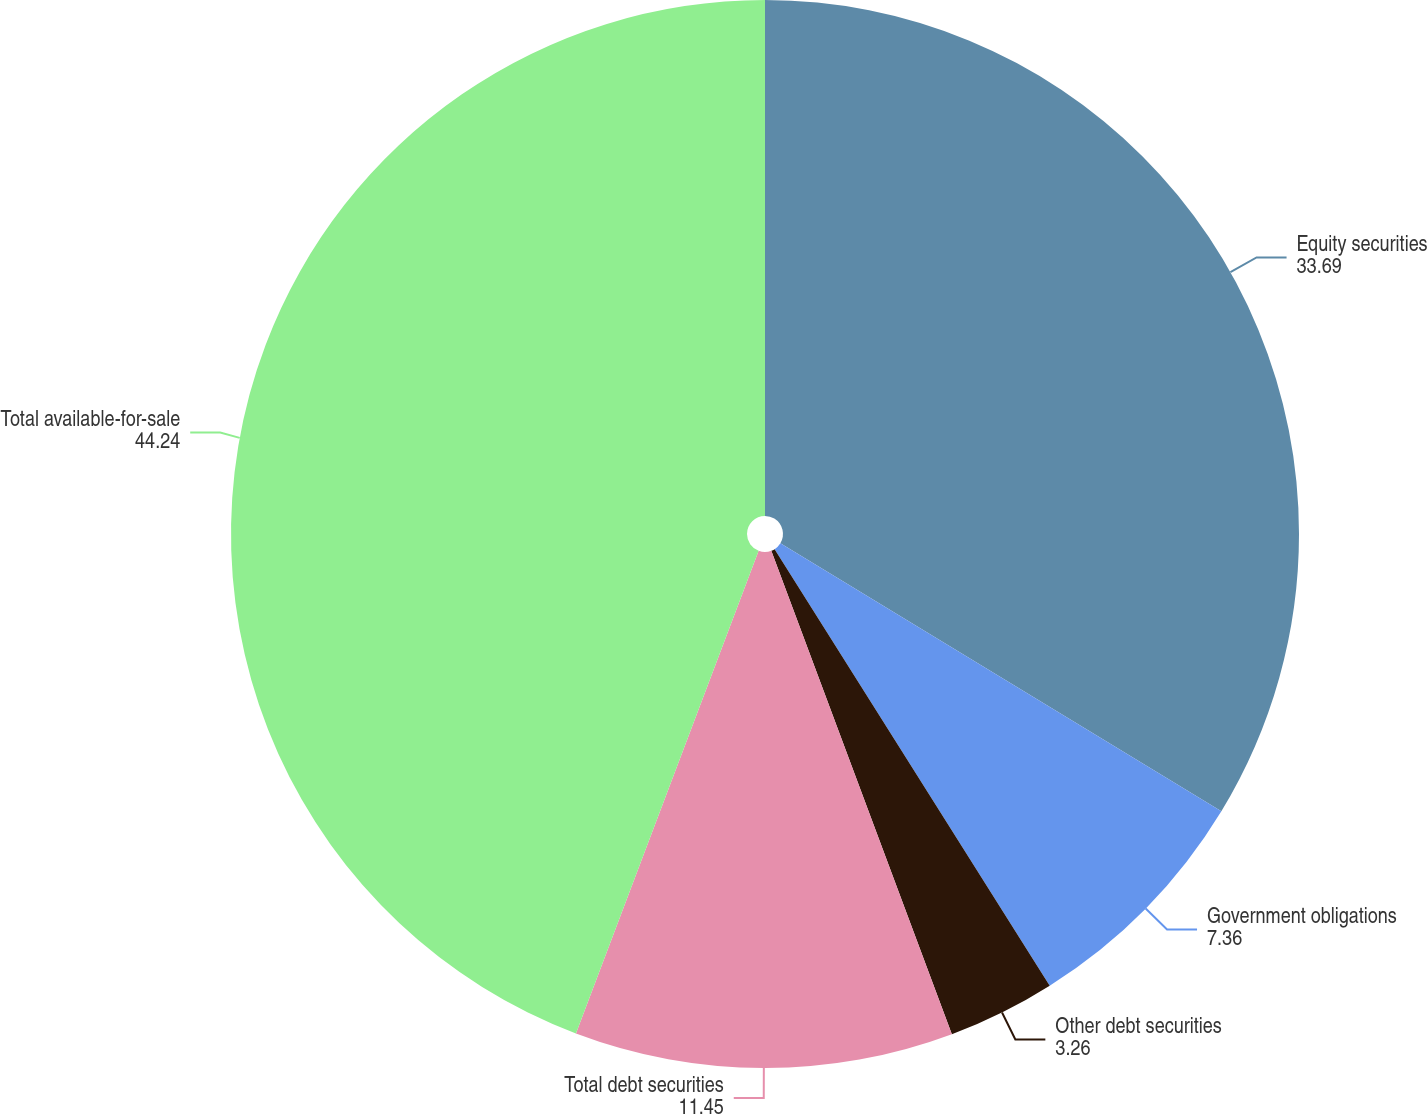Convert chart to OTSL. <chart><loc_0><loc_0><loc_500><loc_500><pie_chart><fcel>Equity securities<fcel>Government obligations<fcel>Other debt securities<fcel>Total debt securities<fcel>Total available-for-sale<nl><fcel>33.69%<fcel>7.36%<fcel>3.26%<fcel>11.45%<fcel>44.24%<nl></chart> 